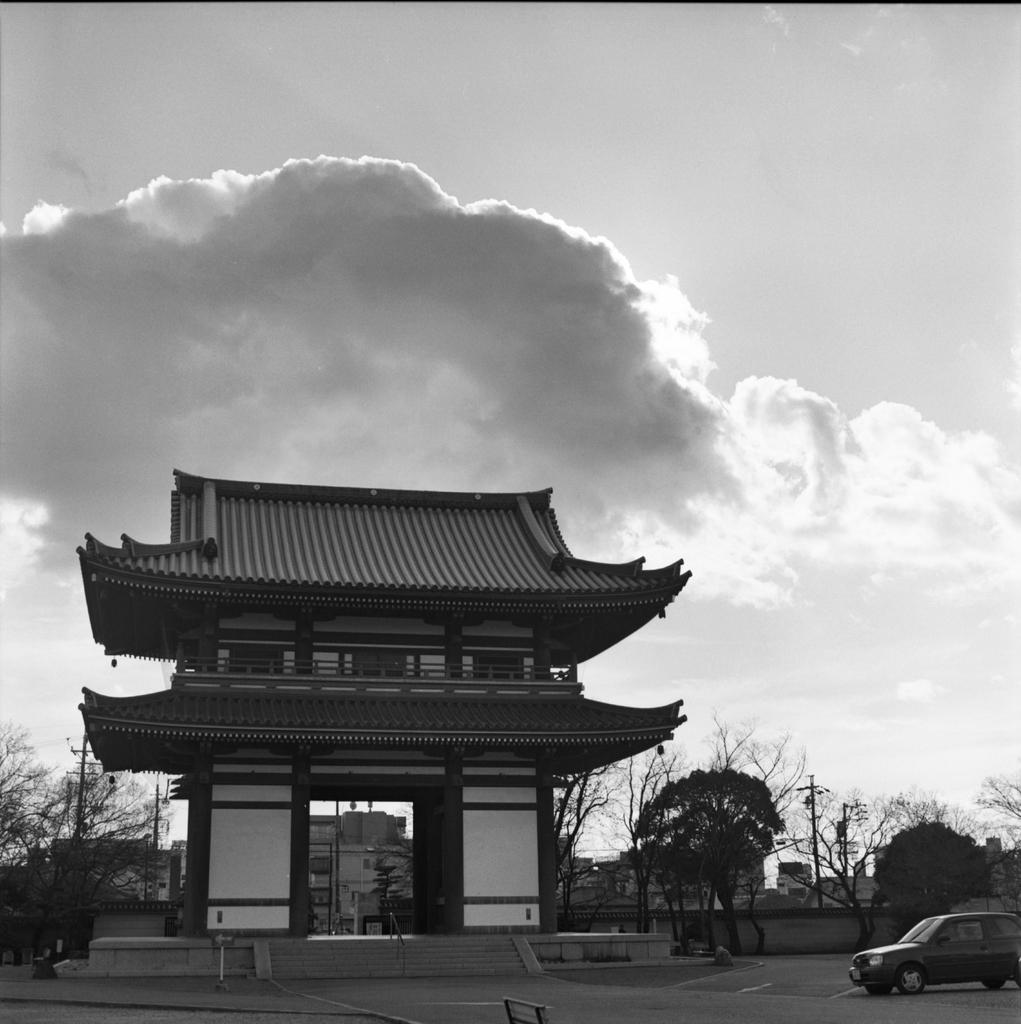What is the main structure in the center of the image? There is an arch in the center of the image. What can be seen on the right side of the image? There is a car, a road, a wall, a pole, and trees on the right side of the image. What is visible in the background of the image? The sky is visible in the background of the image, with clouds present. How many yaks are grazing near the pole in the image? There are no yaks present in the image. What type of pear is hanging from the arch in the image? There is no pear present in the image; the arch is a structure and not a fruit-bearing tree. 